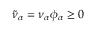Convert formula to latex. <formula><loc_0><loc_0><loc_500><loc_500>\tilde { \nu } _ { \alpha } = \nu _ { \alpha } \phi _ { \alpha } \geq 0</formula> 